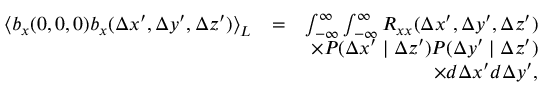Convert formula to latex. <formula><loc_0><loc_0><loc_500><loc_500>\begin{array} { r l r } { \left \langle b _ { x } ( 0 , 0 , 0 ) b _ { x } ( \Delta x ^ { \prime } , \Delta y ^ { \prime } , \Delta z ^ { \prime } ) \right \rangle _ { L } } & { = } & { \int _ { - \infty } ^ { \infty } \int _ { - \infty } ^ { \infty } R _ { x x } ( \Delta x ^ { \prime } , \Delta y ^ { \prime } , \Delta z ^ { \prime } ) } \\ & { \times P ( \Delta x ^ { \prime } | \Delta z ^ { \prime } ) P ( \Delta y ^ { \prime } | \Delta z ^ { \prime } ) } \\ & { \times d \Delta x ^ { \prime } d \Delta y ^ { \prime } , } \end{array}</formula> 